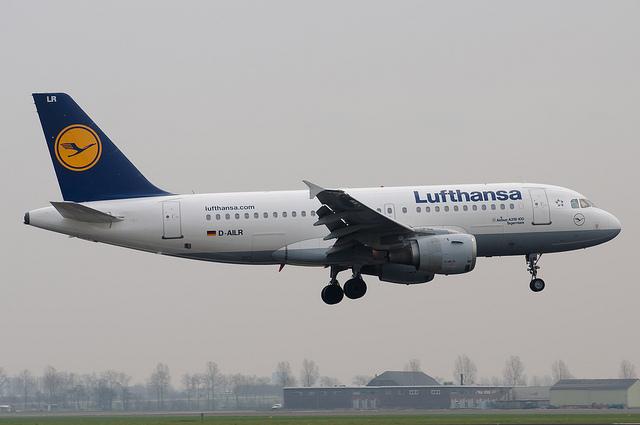Is the plane ready to land?
Give a very brief answer. Yes. Is the plane flying?
Give a very brief answer. Yes. What has the plane been written?
Answer briefly. Lufthansa. How many windows are here?
Quick response, please. 20. What airline is it?
Be succinct. Lufthansa. What does the plane say?
Write a very short answer. Lufthansa. What shape is on the plane tail?
Write a very short answer. Circle. What animal is on yellow?
Write a very short answer. Bird. 